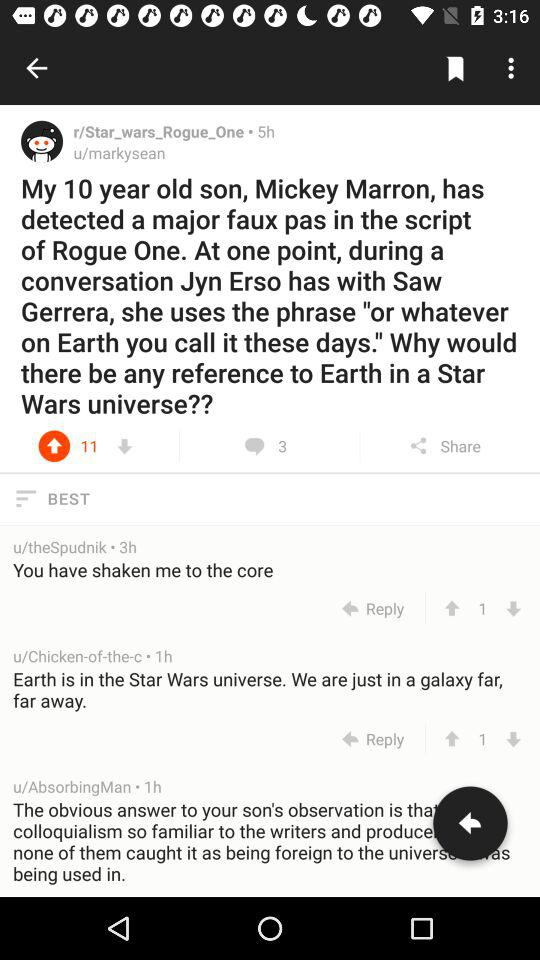How many followers does "r/Star_wars_Rogue_One" have?
When the provided information is insufficient, respond with <no answer>. <no answer> 